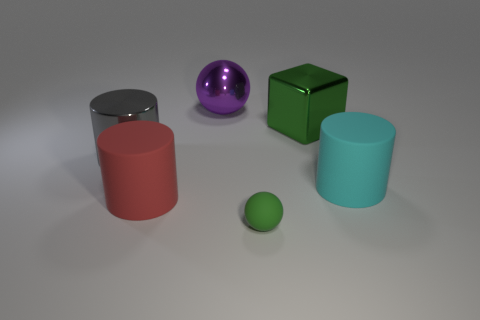Add 1 large red things. How many objects exist? 7 Subtract all large cyan cylinders. How many cylinders are left? 2 Subtract all purple spheres. How many spheres are left? 1 Subtract all red balls. Subtract all cyan blocks. How many balls are left? 2 Subtract all green cubes. Subtract all cyan matte cylinders. How many objects are left? 4 Add 6 big green blocks. How many big green blocks are left? 7 Add 5 big matte spheres. How many big matte spheres exist? 5 Subtract 0 red cubes. How many objects are left? 6 Subtract all spheres. How many objects are left? 4 